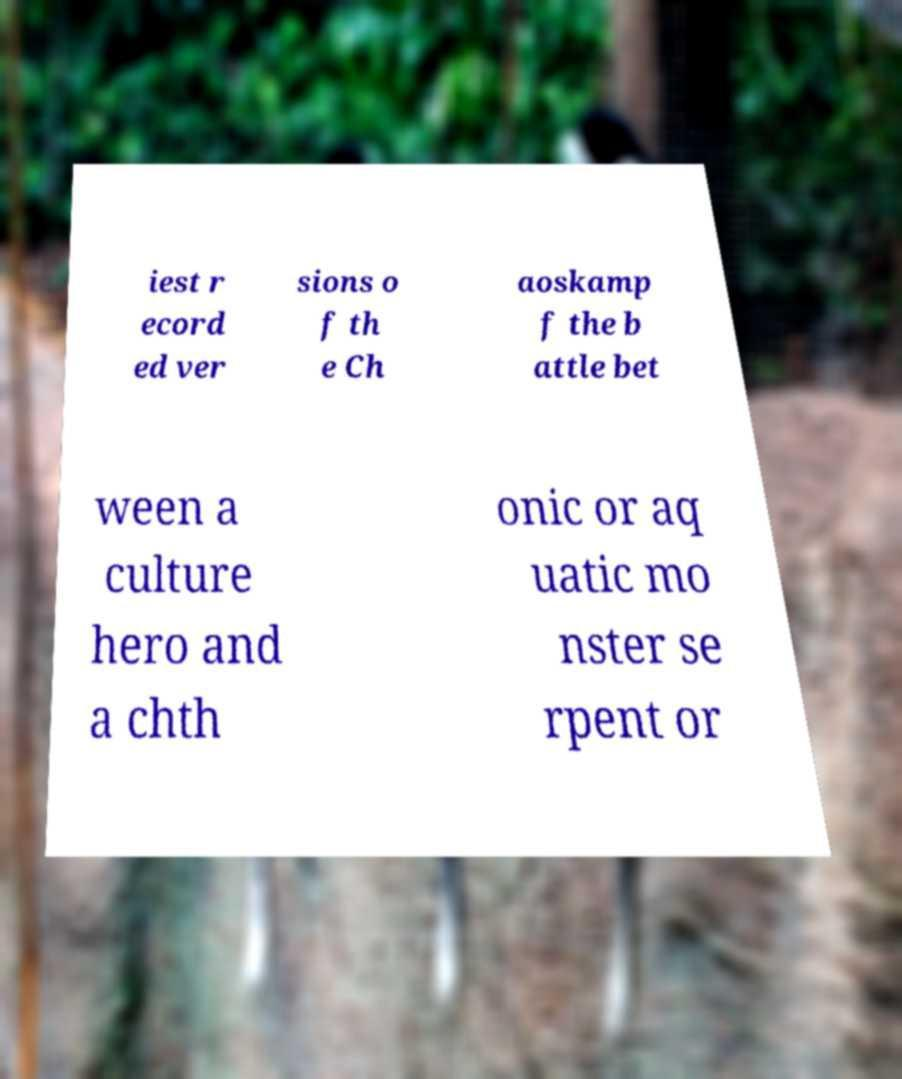There's text embedded in this image that I need extracted. Can you transcribe it verbatim? iest r ecord ed ver sions o f th e Ch aoskamp f the b attle bet ween a culture hero and a chth onic or aq uatic mo nster se rpent or 